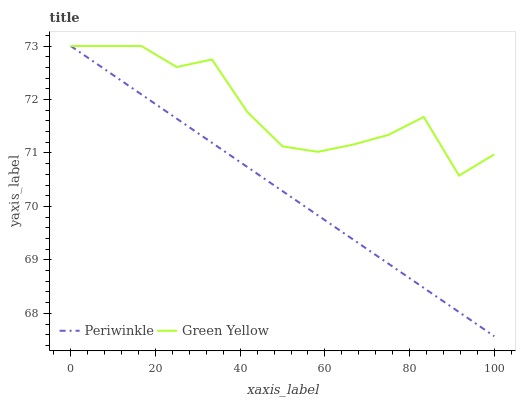Does Periwinkle have the minimum area under the curve?
Answer yes or no. Yes. Does Periwinkle have the maximum area under the curve?
Answer yes or no. No. Is Green Yellow the roughest?
Answer yes or no. Yes. Is Periwinkle the roughest?
Answer yes or no. No. 